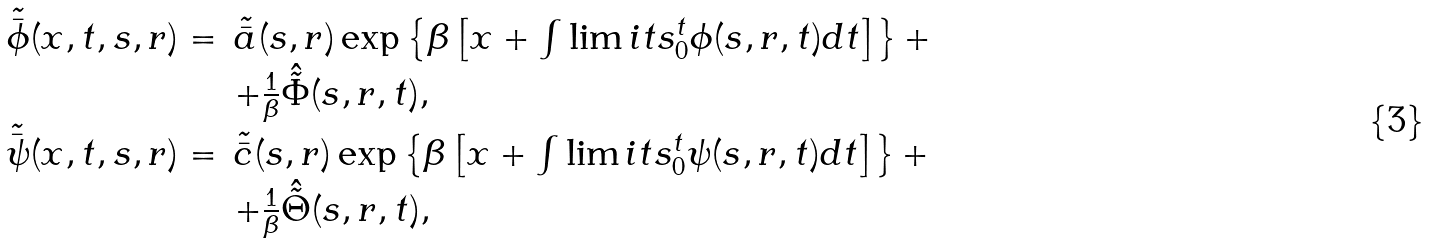Convert formula to latex. <formula><loc_0><loc_0><loc_500><loc_500>\begin{array} { r l } \tilde { \bar { \phi } } ( x , t , s , r ) = & \tilde { \bar { a } } ( s , r ) \exp \left \{ \beta \left [ x + \int \lim i t s _ { 0 } ^ { t } \phi ( s , r , t ) d t \right ] \right \} + \\ & + \frac { 1 } { \beta } \hat { \tilde { \Phi } } ( s , r , t ) , \\ \tilde { \bar { \psi } } ( x , t , s , r ) = & \tilde { \bar { c } } ( s , r ) \exp \left \{ \beta \left [ x + \int \lim i t s _ { 0 } ^ { t } \psi ( s , r , t ) d t \right ] \right \} + \\ & + \frac { 1 } { \beta } \hat { \tilde { \Theta } } ( s , r , t ) , \end{array}</formula> 